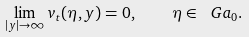Convert formula to latex. <formula><loc_0><loc_0><loc_500><loc_500>\lim _ { | y | \rightarrow \infty } v _ { t } ( \eta , y ) = 0 , \quad \eta \in \ G a _ { 0 } .</formula> 